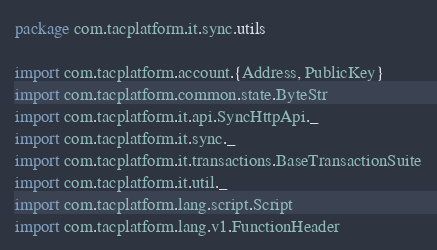<code> <loc_0><loc_0><loc_500><loc_500><_Scala_>package com.tacplatform.it.sync.utils

import com.tacplatform.account.{Address, PublicKey}
import com.tacplatform.common.state.ByteStr
import com.tacplatform.it.api.SyncHttpApi._
import com.tacplatform.it.sync._
import com.tacplatform.it.transactions.BaseTransactionSuite
import com.tacplatform.it.util._
import com.tacplatform.lang.script.Script
import com.tacplatform.lang.v1.FunctionHeader</code> 